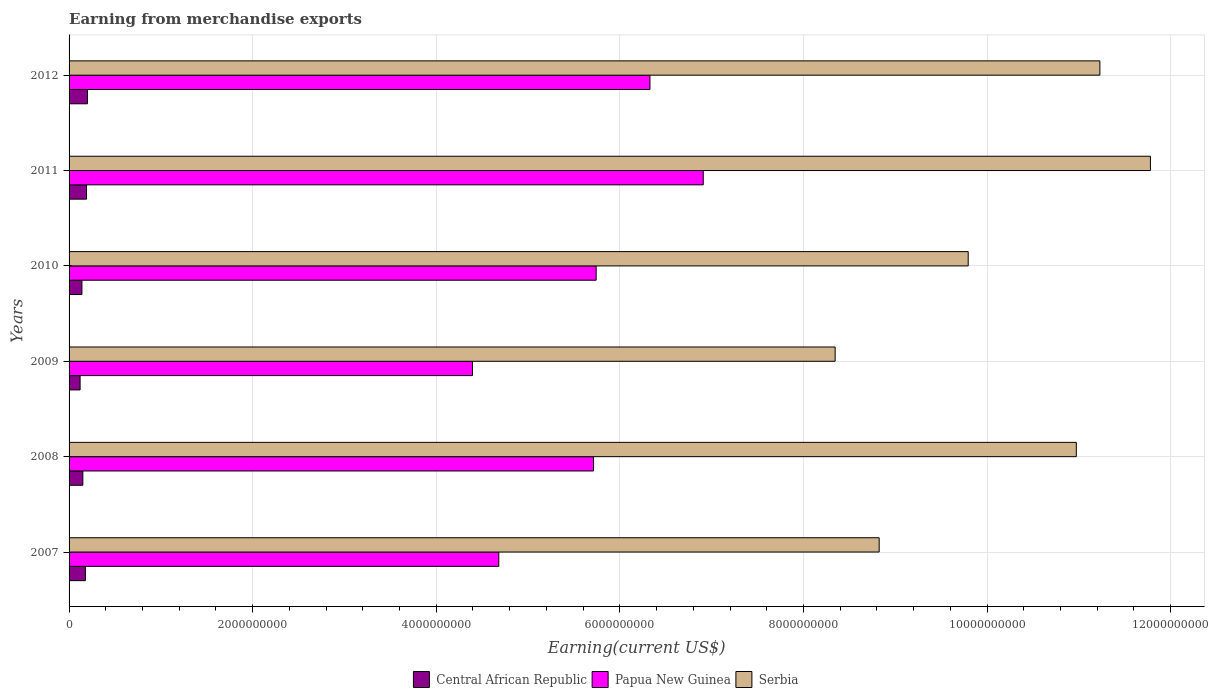How many groups of bars are there?
Your answer should be very brief. 6. Are the number of bars per tick equal to the number of legend labels?
Offer a very short reply. Yes. How many bars are there on the 4th tick from the bottom?
Your response must be concise. 3. What is the label of the 6th group of bars from the top?
Offer a terse response. 2007. What is the amount earned from merchandise exports in Central African Republic in 2008?
Make the answer very short. 1.50e+08. Across all years, what is the maximum amount earned from merchandise exports in Central African Republic?
Offer a terse response. 2.00e+08. Across all years, what is the minimum amount earned from merchandise exports in Serbia?
Keep it short and to the point. 8.35e+09. In which year was the amount earned from merchandise exports in Papua New Guinea minimum?
Your response must be concise. 2009. What is the total amount earned from merchandise exports in Serbia in the graph?
Provide a short and direct response. 6.09e+1. What is the difference between the amount earned from merchandise exports in Papua New Guinea in 2010 and that in 2012?
Provide a short and direct response. -5.86e+08. What is the difference between the amount earned from merchandise exports in Papua New Guinea in 2009 and the amount earned from merchandise exports in Serbia in 2011?
Keep it short and to the point. -7.39e+09. What is the average amount earned from merchandise exports in Central African Republic per year?
Ensure brevity in your answer.  1.63e+08. In the year 2009, what is the difference between the amount earned from merchandise exports in Central African Republic and amount earned from merchandise exports in Papua New Guinea?
Give a very brief answer. -4.27e+09. In how many years, is the amount earned from merchandise exports in Papua New Guinea greater than 10400000000 US$?
Offer a very short reply. 0. Is the amount earned from merchandise exports in Central African Republic in 2009 less than that in 2010?
Keep it short and to the point. Yes. What is the difference between the highest and the second highest amount earned from merchandise exports in Papua New Guinea?
Give a very brief answer. 5.81e+08. What is the difference between the highest and the lowest amount earned from merchandise exports in Central African Republic?
Keep it short and to the point. 8.00e+07. Is the sum of the amount earned from merchandise exports in Central African Republic in 2010 and 2012 greater than the maximum amount earned from merchandise exports in Serbia across all years?
Offer a terse response. No. What does the 1st bar from the top in 2009 represents?
Offer a terse response. Serbia. What does the 3rd bar from the bottom in 2007 represents?
Your answer should be very brief. Serbia. Are the values on the major ticks of X-axis written in scientific E-notation?
Your answer should be very brief. No. Where does the legend appear in the graph?
Provide a short and direct response. Bottom center. What is the title of the graph?
Provide a succinct answer. Earning from merchandise exports. Does "Egypt, Arab Rep." appear as one of the legend labels in the graph?
Offer a very short reply. No. What is the label or title of the X-axis?
Your response must be concise. Earning(current US$). What is the label or title of the Y-axis?
Your answer should be compact. Years. What is the Earning(current US$) in Central African Republic in 2007?
Your response must be concise. 1.78e+08. What is the Earning(current US$) in Papua New Guinea in 2007?
Offer a very short reply. 4.68e+09. What is the Earning(current US$) in Serbia in 2007?
Your response must be concise. 8.82e+09. What is the Earning(current US$) in Central African Republic in 2008?
Offer a very short reply. 1.50e+08. What is the Earning(current US$) in Papua New Guinea in 2008?
Your response must be concise. 5.71e+09. What is the Earning(current US$) in Serbia in 2008?
Offer a very short reply. 1.10e+1. What is the Earning(current US$) of Central African Republic in 2009?
Your response must be concise. 1.20e+08. What is the Earning(current US$) of Papua New Guinea in 2009?
Provide a short and direct response. 4.39e+09. What is the Earning(current US$) in Serbia in 2009?
Provide a short and direct response. 8.35e+09. What is the Earning(current US$) in Central African Republic in 2010?
Your answer should be very brief. 1.40e+08. What is the Earning(current US$) of Papua New Guinea in 2010?
Provide a short and direct response. 5.74e+09. What is the Earning(current US$) in Serbia in 2010?
Your answer should be very brief. 9.79e+09. What is the Earning(current US$) in Central African Republic in 2011?
Make the answer very short. 1.90e+08. What is the Earning(current US$) in Papua New Guinea in 2011?
Your answer should be very brief. 6.91e+09. What is the Earning(current US$) in Serbia in 2011?
Your answer should be compact. 1.18e+1. What is the Earning(current US$) in Papua New Guinea in 2012?
Make the answer very short. 6.33e+09. What is the Earning(current US$) in Serbia in 2012?
Your response must be concise. 1.12e+1. Across all years, what is the maximum Earning(current US$) of Papua New Guinea?
Your response must be concise. 6.91e+09. Across all years, what is the maximum Earning(current US$) of Serbia?
Give a very brief answer. 1.18e+1. Across all years, what is the minimum Earning(current US$) in Central African Republic?
Offer a very short reply. 1.20e+08. Across all years, what is the minimum Earning(current US$) of Papua New Guinea?
Provide a short and direct response. 4.39e+09. Across all years, what is the minimum Earning(current US$) in Serbia?
Make the answer very short. 8.35e+09. What is the total Earning(current US$) in Central African Republic in the graph?
Ensure brevity in your answer.  9.78e+08. What is the total Earning(current US$) in Papua New Guinea in the graph?
Your answer should be compact. 3.38e+1. What is the total Earning(current US$) in Serbia in the graph?
Your answer should be very brief. 6.09e+1. What is the difference between the Earning(current US$) in Central African Republic in 2007 and that in 2008?
Give a very brief answer. 2.78e+07. What is the difference between the Earning(current US$) in Papua New Guinea in 2007 and that in 2008?
Ensure brevity in your answer.  -1.03e+09. What is the difference between the Earning(current US$) in Serbia in 2007 and that in 2008?
Offer a very short reply. -2.15e+09. What is the difference between the Earning(current US$) in Central African Republic in 2007 and that in 2009?
Provide a short and direct response. 5.78e+07. What is the difference between the Earning(current US$) of Papua New Guinea in 2007 and that in 2009?
Your answer should be very brief. 2.87e+08. What is the difference between the Earning(current US$) in Serbia in 2007 and that in 2009?
Give a very brief answer. 4.80e+08. What is the difference between the Earning(current US$) in Central African Republic in 2007 and that in 2010?
Give a very brief answer. 3.78e+07. What is the difference between the Earning(current US$) of Papua New Guinea in 2007 and that in 2010?
Your answer should be compact. -1.06e+09. What is the difference between the Earning(current US$) in Serbia in 2007 and that in 2010?
Your answer should be compact. -9.70e+08. What is the difference between the Earning(current US$) in Central African Republic in 2007 and that in 2011?
Offer a very short reply. -1.22e+07. What is the difference between the Earning(current US$) in Papua New Guinea in 2007 and that in 2011?
Offer a terse response. -2.23e+09. What is the difference between the Earning(current US$) of Serbia in 2007 and that in 2011?
Your answer should be very brief. -2.95e+09. What is the difference between the Earning(current US$) in Central African Republic in 2007 and that in 2012?
Offer a very short reply. -2.22e+07. What is the difference between the Earning(current US$) in Papua New Guinea in 2007 and that in 2012?
Your response must be concise. -1.65e+09. What is the difference between the Earning(current US$) in Serbia in 2007 and that in 2012?
Provide a short and direct response. -2.40e+09. What is the difference between the Earning(current US$) in Central African Republic in 2008 and that in 2009?
Give a very brief answer. 3.00e+07. What is the difference between the Earning(current US$) of Papua New Guinea in 2008 and that in 2009?
Keep it short and to the point. 1.32e+09. What is the difference between the Earning(current US$) in Serbia in 2008 and that in 2009?
Ensure brevity in your answer.  2.63e+09. What is the difference between the Earning(current US$) in Central African Republic in 2008 and that in 2010?
Ensure brevity in your answer.  1.00e+07. What is the difference between the Earning(current US$) in Papua New Guinea in 2008 and that in 2010?
Make the answer very short. -2.84e+07. What is the difference between the Earning(current US$) in Serbia in 2008 and that in 2010?
Provide a short and direct response. 1.18e+09. What is the difference between the Earning(current US$) in Central African Republic in 2008 and that in 2011?
Give a very brief answer. -4.00e+07. What is the difference between the Earning(current US$) of Papua New Guinea in 2008 and that in 2011?
Your response must be concise. -1.20e+09. What is the difference between the Earning(current US$) of Serbia in 2008 and that in 2011?
Offer a very short reply. -8.07e+08. What is the difference between the Earning(current US$) of Central African Republic in 2008 and that in 2012?
Your answer should be very brief. -5.00e+07. What is the difference between the Earning(current US$) in Papua New Guinea in 2008 and that in 2012?
Your answer should be very brief. -6.14e+08. What is the difference between the Earning(current US$) in Serbia in 2008 and that in 2012?
Keep it short and to the point. -2.57e+08. What is the difference between the Earning(current US$) of Central African Republic in 2009 and that in 2010?
Give a very brief answer. -2.00e+07. What is the difference between the Earning(current US$) of Papua New Guinea in 2009 and that in 2010?
Keep it short and to the point. -1.35e+09. What is the difference between the Earning(current US$) of Serbia in 2009 and that in 2010?
Offer a very short reply. -1.45e+09. What is the difference between the Earning(current US$) in Central African Republic in 2009 and that in 2011?
Keep it short and to the point. -7.00e+07. What is the difference between the Earning(current US$) in Papua New Guinea in 2009 and that in 2011?
Offer a terse response. -2.51e+09. What is the difference between the Earning(current US$) of Serbia in 2009 and that in 2011?
Keep it short and to the point. -3.43e+09. What is the difference between the Earning(current US$) of Central African Republic in 2009 and that in 2012?
Give a very brief answer. -8.00e+07. What is the difference between the Earning(current US$) of Papua New Guinea in 2009 and that in 2012?
Offer a very short reply. -1.93e+09. What is the difference between the Earning(current US$) in Serbia in 2009 and that in 2012?
Your response must be concise. -2.88e+09. What is the difference between the Earning(current US$) in Central African Republic in 2010 and that in 2011?
Your answer should be compact. -5.00e+07. What is the difference between the Earning(current US$) of Papua New Guinea in 2010 and that in 2011?
Keep it short and to the point. -1.17e+09. What is the difference between the Earning(current US$) of Serbia in 2010 and that in 2011?
Your response must be concise. -1.98e+09. What is the difference between the Earning(current US$) of Central African Republic in 2010 and that in 2012?
Your answer should be very brief. -6.00e+07. What is the difference between the Earning(current US$) in Papua New Guinea in 2010 and that in 2012?
Give a very brief answer. -5.86e+08. What is the difference between the Earning(current US$) in Serbia in 2010 and that in 2012?
Offer a very short reply. -1.43e+09. What is the difference between the Earning(current US$) in Central African Republic in 2011 and that in 2012?
Your answer should be compact. -1.00e+07. What is the difference between the Earning(current US$) of Papua New Guinea in 2011 and that in 2012?
Provide a succinct answer. 5.81e+08. What is the difference between the Earning(current US$) of Serbia in 2011 and that in 2012?
Offer a terse response. 5.50e+08. What is the difference between the Earning(current US$) of Central African Republic in 2007 and the Earning(current US$) of Papua New Guinea in 2008?
Your answer should be very brief. -5.54e+09. What is the difference between the Earning(current US$) of Central African Republic in 2007 and the Earning(current US$) of Serbia in 2008?
Ensure brevity in your answer.  -1.08e+1. What is the difference between the Earning(current US$) of Papua New Guinea in 2007 and the Earning(current US$) of Serbia in 2008?
Your answer should be very brief. -6.29e+09. What is the difference between the Earning(current US$) in Central African Republic in 2007 and the Earning(current US$) in Papua New Guinea in 2009?
Your response must be concise. -4.22e+09. What is the difference between the Earning(current US$) in Central African Republic in 2007 and the Earning(current US$) in Serbia in 2009?
Offer a terse response. -8.17e+09. What is the difference between the Earning(current US$) in Papua New Guinea in 2007 and the Earning(current US$) in Serbia in 2009?
Offer a terse response. -3.66e+09. What is the difference between the Earning(current US$) of Central African Republic in 2007 and the Earning(current US$) of Papua New Guinea in 2010?
Your response must be concise. -5.56e+09. What is the difference between the Earning(current US$) of Central African Republic in 2007 and the Earning(current US$) of Serbia in 2010?
Your answer should be compact. -9.62e+09. What is the difference between the Earning(current US$) in Papua New Guinea in 2007 and the Earning(current US$) in Serbia in 2010?
Offer a terse response. -5.11e+09. What is the difference between the Earning(current US$) of Central African Republic in 2007 and the Earning(current US$) of Papua New Guinea in 2011?
Your answer should be compact. -6.73e+09. What is the difference between the Earning(current US$) of Central African Republic in 2007 and the Earning(current US$) of Serbia in 2011?
Provide a short and direct response. -1.16e+1. What is the difference between the Earning(current US$) of Papua New Guinea in 2007 and the Earning(current US$) of Serbia in 2011?
Your response must be concise. -7.10e+09. What is the difference between the Earning(current US$) of Central African Republic in 2007 and the Earning(current US$) of Papua New Guinea in 2012?
Offer a very short reply. -6.15e+09. What is the difference between the Earning(current US$) of Central African Republic in 2007 and the Earning(current US$) of Serbia in 2012?
Give a very brief answer. -1.11e+1. What is the difference between the Earning(current US$) in Papua New Guinea in 2007 and the Earning(current US$) in Serbia in 2012?
Ensure brevity in your answer.  -6.55e+09. What is the difference between the Earning(current US$) of Central African Republic in 2008 and the Earning(current US$) of Papua New Guinea in 2009?
Ensure brevity in your answer.  -4.24e+09. What is the difference between the Earning(current US$) in Central African Republic in 2008 and the Earning(current US$) in Serbia in 2009?
Your answer should be compact. -8.20e+09. What is the difference between the Earning(current US$) of Papua New Guinea in 2008 and the Earning(current US$) of Serbia in 2009?
Keep it short and to the point. -2.63e+09. What is the difference between the Earning(current US$) of Central African Republic in 2008 and the Earning(current US$) of Papua New Guinea in 2010?
Offer a terse response. -5.59e+09. What is the difference between the Earning(current US$) of Central African Republic in 2008 and the Earning(current US$) of Serbia in 2010?
Give a very brief answer. -9.64e+09. What is the difference between the Earning(current US$) in Papua New Guinea in 2008 and the Earning(current US$) in Serbia in 2010?
Your answer should be very brief. -4.08e+09. What is the difference between the Earning(current US$) of Central African Republic in 2008 and the Earning(current US$) of Papua New Guinea in 2011?
Provide a succinct answer. -6.76e+09. What is the difference between the Earning(current US$) of Central African Republic in 2008 and the Earning(current US$) of Serbia in 2011?
Provide a succinct answer. -1.16e+1. What is the difference between the Earning(current US$) of Papua New Guinea in 2008 and the Earning(current US$) of Serbia in 2011?
Give a very brief answer. -6.07e+09. What is the difference between the Earning(current US$) in Central African Republic in 2008 and the Earning(current US$) in Papua New Guinea in 2012?
Your answer should be compact. -6.18e+09. What is the difference between the Earning(current US$) in Central African Republic in 2008 and the Earning(current US$) in Serbia in 2012?
Your response must be concise. -1.11e+1. What is the difference between the Earning(current US$) in Papua New Guinea in 2008 and the Earning(current US$) in Serbia in 2012?
Provide a short and direct response. -5.52e+09. What is the difference between the Earning(current US$) of Central African Republic in 2009 and the Earning(current US$) of Papua New Guinea in 2010?
Your answer should be very brief. -5.62e+09. What is the difference between the Earning(current US$) in Central African Republic in 2009 and the Earning(current US$) in Serbia in 2010?
Keep it short and to the point. -9.67e+09. What is the difference between the Earning(current US$) in Papua New Guinea in 2009 and the Earning(current US$) in Serbia in 2010?
Your answer should be compact. -5.40e+09. What is the difference between the Earning(current US$) in Central African Republic in 2009 and the Earning(current US$) in Papua New Guinea in 2011?
Make the answer very short. -6.79e+09. What is the difference between the Earning(current US$) in Central African Republic in 2009 and the Earning(current US$) in Serbia in 2011?
Give a very brief answer. -1.17e+1. What is the difference between the Earning(current US$) in Papua New Guinea in 2009 and the Earning(current US$) in Serbia in 2011?
Ensure brevity in your answer.  -7.39e+09. What is the difference between the Earning(current US$) in Central African Republic in 2009 and the Earning(current US$) in Papua New Guinea in 2012?
Provide a succinct answer. -6.21e+09. What is the difference between the Earning(current US$) of Central African Republic in 2009 and the Earning(current US$) of Serbia in 2012?
Offer a terse response. -1.11e+1. What is the difference between the Earning(current US$) of Papua New Guinea in 2009 and the Earning(current US$) of Serbia in 2012?
Provide a short and direct response. -6.83e+09. What is the difference between the Earning(current US$) in Central African Republic in 2010 and the Earning(current US$) in Papua New Guinea in 2011?
Provide a short and direct response. -6.77e+09. What is the difference between the Earning(current US$) of Central African Republic in 2010 and the Earning(current US$) of Serbia in 2011?
Keep it short and to the point. -1.16e+1. What is the difference between the Earning(current US$) in Papua New Guinea in 2010 and the Earning(current US$) in Serbia in 2011?
Ensure brevity in your answer.  -6.04e+09. What is the difference between the Earning(current US$) in Central African Republic in 2010 and the Earning(current US$) in Papua New Guinea in 2012?
Provide a short and direct response. -6.19e+09. What is the difference between the Earning(current US$) of Central African Republic in 2010 and the Earning(current US$) of Serbia in 2012?
Provide a short and direct response. -1.11e+1. What is the difference between the Earning(current US$) of Papua New Guinea in 2010 and the Earning(current US$) of Serbia in 2012?
Your response must be concise. -5.49e+09. What is the difference between the Earning(current US$) of Central African Republic in 2011 and the Earning(current US$) of Papua New Guinea in 2012?
Give a very brief answer. -6.14e+09. What is the difference between the Earning(current US$) of Central African Republic in 2011 and the Earning(current US$) of Serbia in 2012?
Make the answer very short. -1.10e+1. What is the difference between the Earning(current US$) in Papua New Guinea in 2011 and the Earning(current US$) in Serbia in 2012?
Provide a succinct answer. -4.32e+09. What is the average Earning(current US$) in Central African Republic per year?
Give a very brief answer. 1.63e+08. What is the average Earning(current US$) of Papua New Guinea per year?
Your answer should be very brief. 5.63e+09. What is the average Earning(current US$) in Serbia per year?
Keep it short and to the point. 1.02e+1. In the year 2007, what is the difference between the Earning(current US$) in Central African Republic and Earning(current US$) in Papua New Guinea?
Provide a short and direct response. -4.50e+09. In the year 2007, what is the difference between the Earning(current US$) of Central African Republic and Earning(current US$) of Serbia?
Your answer should be very brief. -8.65e+09. In the year 2007, what is the difference between the Earning(current US$) in Papua New Guinea and Earning(current US$) in Serbia?
Your answer should be compact. -4.14e+09. In the year 2008, what is the difference between the Earning(current US$) in Central African Republic and Earning(current US$) in Papua New Guinea?
Provide a succinct answer. -5.56e+09. In the year 2008, what is the difference between the Earning(current US$) in Central African Republic and Earning(current US$) in Serbia?
Give a very brief answer. -1.08e+1. In the year 2008, what is the difference between the Earning(current US$) in Papua New Guinea and Earning(current US$) in Serbia?
Your answer should be compact. -5.26e+09. In the year 2009, what is the difference between the Earning(current US$) in Central African Republic and Earning(current US$) in Papua New Guinea?
Keep it short and to the point. -4.27e+09. In the year 2009, what is the difference between the Earning(current US$) in Central African Republic and Earning(current US$) in Serbia?
Ensure brevity in your answer.  -8.23e+09. In the year 2009, what is the difference between the Earning(current US$) of Papua New Guinea and Earning(current US$) of Serbia?
Ensure brevity in your answer.  -3.95e+09. In the year 2010, what is the difference between the Earning(current US$) in Central African Republic and Earning(current US$) in Papua New Guinea?
Your response must be concise. -5.60e+09. In the year 2010, what is the difference between the Earning(current US$) of Central African Republic and Earning(current US$) of Serbia?
Ensure brevity in your answer.  -9.65e+09. In the year 2010, what is the difference between the Earning(current US$) of Papua New Guinea and Earning(current US$) of Serbia?
Provide a succinct answer. -4.05e+09. In the year 2011, what is the difference between the Earning(current US$) of Central African Republic and Earning(current US$) of Papua New Guinea?
Ensure brevity in your answer.  -6.72e+09. In the year 2011, what is the difference between the Earning(current US$) in Central African Republic and Earning(current US$) in Serbia?
Keep it short and to the point. -1.16e+1. In the year 2011, what is the difference between the Earning(current US$) of Papua New Guinea and Earning(current US$) of Serbia?
Keep it short and to the point. -4.87e+09. In the year 2012, what is the difference between the Earning(current US$) of Central African Republic and Earning(current US$) of Papua New Guinea?
Offer a terse response. -6.13e+09. In the year 2012, what is the difference between the Earning(current US$) in Central African Republic and Earning(current US$) in Serbia?
Your answer should be very brief. -1.10e+1. In the year 2012, what is the difference between the Earning(current US$) in Papua New Guinea and Earning(current US$) in Serbia?
Ensure brevity in your answer.  -4.90e+09. What is the ratio of the Earning(current US$) in Central African Republic in 2007 to that in 2008?
Your response must be concise. 1.19. What is the ratio of the Earning(current US$) of Papua New Guinea in 2007 to that in 2008?
Offer a terse response. 0.82. What is the ratio of the Earning(current US$) of Serbia in 2007 to that in 2008?
Provide a succinct answer. 0.8. What is the ratio of the Earning(current US$) of Central African Republic in 2007 to that in 2009?
Provide a short and direct response. 1.48. What is the ratio of the Earning(current US$) of Papua New Guinea in 2007 to that in 2009?
Give a very brief answer. 1.07. What is the ratio of the Earning(current US$) of Serbia in 2007 to that in 2009?
Offer a terse response. 1.06. What is the ratio of the Earning(current US$) in Central African Republic in 2007 to that in 2010?
Offer a very short reply. 1.27. What is the ratio of the Earning(current US$) in Papua New Guinea in 2007 to that in 2010?
Your answer should be compact. 0.82. What is the ratio of the Earning(current US$) in Serbia in 2007 to that in 2010?
Give a very brief answer. 0.9. What is the ratio of the Earning(current US$) of Central African Republic in 2007 to that in 2011?
Offer a terse response. 0.94. What is the ratio of the Earning(current US$) in Papua New Guinea in 2007 to that in 2011?
Your answer should be very brief. 0.68. What is the ratio of the Earning(current US$) in Serbia in 2007 to that in 2011?
Offer a very short reply. 0.75. What is the ratio of the Earning(current US$) in Papua New Guinea in 2007 to that in 2012?
Keep it short and to the point. 0.74. What is the ratio of the Earning(current US$) in Serbia in 2007 to that in 2012?
Keep it short and to the point. 0.79. What is the ratio of the Earning(current US$) of Central African Republic in 2008 to that in 2009?
Give a very brief answer. 1.25. What is the ratio of the Earning(current US$) of Papua New Guinea in 2008 to that in 2009?
Make the answer very short. 1.3. What is the ratio of the Earning(current US$) of Serbia in 2008 to that in 2009?
Make the answer very short. 1.31. What is the ratio of the Earning(current US$) of Central African Republic in 2008 to that in 2010?
Offer a terse response. 1.07. What is the ratio of the Earning(current US$) of Serbia in 2008 to that in 2010?
Offer a terse response. 1.12. What is the ratio of the Earning(current US$) of Central African Republic in 2008 to that in 2011?
Offer a terse response. 0.79. What is the ratio of the Earning(current US$) in Papua New Guinea in 2008 to that in 2011?
Offer a very short reply. 0.83. What is the ratio of the Earning(current US$) in Serbia in 2008 to that in 2011?
Offer a terse response. 0.93. What is the ratio of the Earning(current US$) in Papua New Guinea in 2008 to that in 2012?
Your response must be concise. 0.9. What is the ratio of the Earning(current US$) of Serbia in 2008 to that in 2012?
Your answer should be very brief. 0.98. What is the ratio of the Earning(current US$) in Papua New Guinea in 2009 to that in 2010?
Offer a very short reply. 0.77. What is the ratio of the Earning(current US$) in Serbia in 2009 to that in 2010?
Give a very brief answer. 0.85. What is the ratio of the Earning(current US$) in Central African Republic in 2009 to that in 2011?
Keep it short and to the point. 0.63. What is the ratio of the Earning(current US$) of Papua New Guinea in 2009 to that in 2011?
Provide a succinct answer. 0.64. What is the ratio of the Earning(current US$) of Serbia in 2009 to that in 2011?
Keep it short and to the point. 0.71. What is the ratio of the Earning(current US$) in Papua New Guinea in 2009 to that in 2012?
Make the answer very short. 0.69. What is the ratio of the Earning(current US$) of Serbia in 2009 to that in 2012?
Your answer should be very brief. 0.74. What is the ratio of the Earning(current US$) in Central African Republic in 2010 to that in 2011?
Offer a terse response. 0.74. What is the ratio of the Earning(current US$) in Papua New Guinea in 2010 to that in 2011?
Make the answer very short. 0.83. What is the ratio of the Earning(current US$) of Serbia in 2010 to that in 2011?
Offer a terse response. 0.83. What is the ratio of the Earning(current US$) of Papua New Guinea in 2010 to that in 2012?
Your response must be concise. 0.91. What is the ratio of the Earning(current US$) in Serbia in 2010 to that in 2012?
Keep it short and to the point. 0.87. What is the ratio of the Earning(current US$) in Central African Republic in 2011 to that in 2012?
Ensure brevity in your answer.  0.95. What is the ratio of the Earning(current US$) of Papua New Guinea in 2011 to that in 2012?
Provide a succinct answer. 1.09. What is the ratio of the Earning(current US$) in Serbia in 2011 to that in 2012?
Give a very brief answer. 1.05. What is the difference between the highest and the second highest Earning(current US$) of Papua New Guinea?
Offer a very short reply. 5.81e+08. What is the difference between the highest and the second highest Earning(current US$) of Serbia?
Your response must be concise. 5.50e+08. What is the difference between the highest and the lowest Earning(current US$) of Central African Republic?
Your response must be concise. 8.00e+07. What is the difference between the highest and the lowest Earning(current US$) of Papua New Guinea?
Give a very brief answer. 2.51e+09. What is the difference between the highest and the lowest Earning(current US$) in Serbia?
Your response must be concise. 3.43e+09. 